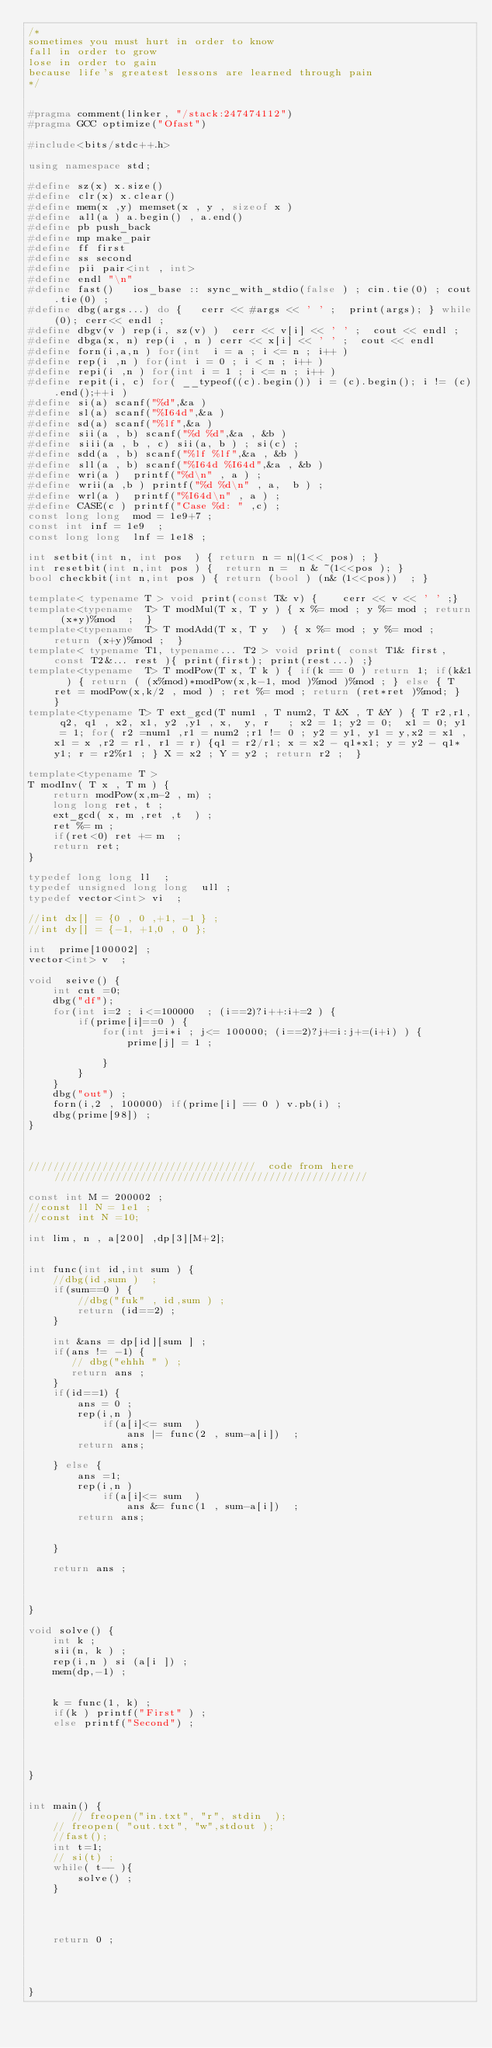<code> <loc_0><loc_0><loc_500><loc_500><_C++_>/*
sometimes you must hurt in order to know 
fall in order to grow
lose in order to gain  
because life's greatest lessons are learned through pain
*/


#pragma comment(linker, "/stack:247474112")
#pragma GCC optimize("Ofast")

#include<bits/stdc++.h>
 
using namespace std;
 
#define sz(x) x.size()
#define clr(x) x.clear()
#define mem(x ,y) memset(x , y , sizeof x )
#define all(a ) a.begin() , a.end()
#define pb push_back
#define mp make_pair
#define ff first
#define ss second
#define pii pair<int , int>
#define endl "\n"
#define fast()   ios_base :: sync_with_stdio(false ) ; cin.tie(0) ; cout.tie(0) ;
#define dbg(args...) do {   cerr << #args << ' ' ;  print(args); } while(0); cerr<< endl ;
#define dbgv(v ) rep(i, sz(v) )  cerr << v[i] << ' ' ;  cout << endl ;
#define dbga(x, n) rep(i , n ) cerr << x[i] << ' ' ;  cout << endl
#define forn(i,a,n ) for(int  i = a ; i <= n ; i++ )
#define rep(i ,n ) for(int i = 0 ; i < n ; i++ )
#define repi(i ,n ) for(int i = 1 ; i <= n ; i++ )
#define repit(i, c) for( __typeof((c).begin()) i = (c).begin(); i != (c).end();++i )
#define si(a) scanf("%d",&a )
#define sl(a) scanf("%I64d",&a )
#define sd(a) scanf("%lf",&a )
#define sii(a , b) scanf("%d %d",&a , &b )
#define siii(a , b , c) sii(a, b ) ; si(c) ;
#define sdd(a , b) scanf("%lf %lf",&a , &b )
#define sll(a , b) scanf("%I64d %I64d",&a , &b )
#define wri(a )  printf("%d\n" , a ) ;
#define wrii(a ,b ) printf("%d %d\n" , a,  b ) ;
#define wrl(a )  printf("%I64d\n" , a ) ;
#define CASE(c ) printf("Case %d: " ,c) ;
const long long  mod = 1e9+7 ;
const int inf = 1e9  ;
const long long  lnf = 1e18 ;
 
int setbit(int n, int pos  ) { return n = n|(1<< pos) ; }
int resetbit(int n,int pos ) {  return n =  n & ~(1<<pos ); }
bool checkbit(int n,int pos ) { return (bool ) (n& (1<<pos))  ; }

template< typename T > void print(const T& v) {    cerr << v << ' ' ;}
template<typename  T> T modMul(T x, T y ) { x %= mod ; y %= mod ; return (x*y)%mod  ;  }
template<typename  T> T modAdd(T x, T y  ) { x %= mod ; y %= mod ; return (x+y)%mod ;  }
template< typename T1, typename... T2 > void print( const T1& first, const T2&... rest ){ print(first); print(rest...) ;}
template<typename  T> T modPow(T x, T k ) { if(k == 0 ) return 1; if(k&1  ) { return ( (x%mod)*modPow(x,k-1, mod )%mod )%mod ; } else { T ret = modPow(x,k/2 , mod ) ; ret %= mod ; return (ret*ret )%mod; } }
template<typename T> T ext_gcd(T num1 , T num2, T &X , T &Y ) { T r2,r1, q2, q1 , x2, x1, y2 ,y1 , x,  y, r   ; x2 = 1; y2 = 0;  x1 = 0; y1 = 1; for( r2 =num1 ,r1 = num2 ;r1 != 0 ; y2 = y1, y1 = y,x2 = x1 ,x1 = x ,r2 = r1, r1 = r) {q1 = r2/r1; x = x2 - q1*x1; y = y2 - q1*y1; r = r2%r1 ; } X = x2 ; Y = y2 ; return r2 ;  } 

template<typename T >
T modInv( T x , T m ) {  
    return modPow(x,m-2 , m) ; 
    long long ret, t ;
    ext_gcd( x, m ,ret ,t  ) ;
    ret %= m ;
    if(ret<0) ret += m  ;
    return ret;
}

typedef long long ll  ;
typedef unsigned long long  ull ;
typedef vector<int> vi  ;

//int dx[] = {0 , 0 ,+1, -1 } ;
//int dy[] = {-1, +1,0 , 0 };

int  prime[100002] ; 
vector<int> v  ;

void  seive() {
    int cnt =0; 
    dbg("df");
    for(int i=2 ; i<=100000  ; (i==2)?i++:i+=2 ) {
        if(prime[i]==0 ) {
            for(int j=i*i ; j<= 100000; (i==2)?j+=i:j+=(i+i) ) {
                prime[j] = 1 ; 
                
            }
        }
    }
    dbg("out") ;
    forn(i,2 , 100000) if(prime[i] == 0 ) v.pb(i) ; 
    dbg(prime[98]) ;
}


 
/////////////////////////////////////  code from here ///////////////////////////////////////////////////

const int M = 200002 ;  
//const ll N = 1e1 ;
//const int N =10;

int lim, n , a[200] ,dp[3][M+2];


int func(int id,int sum ) {
    //dbg(id,sum )  ;
    if(sum==0 ) {
        //dbg("fuk" , id,sum ) ;
        return (id==2) ;
    }

    int &ans = dp[id][sum ] ;
    if(ans != -1) {
       // dbg("ehhh " ) ;
       return ans ;
    }
    if(id==1) {
        ans = 0 ;
        rep(i,n ) 
            if(a[i]<= sum  )
                ans |= func(2 , sum-a[i])  ;
        return ans; 

    } else {
        ans =1;
        rep(i,n ) 
            if(a[i]<= sum  )
                ans &= func(1 , sum-a[i])  ;
        return ans; 
        

    }

    return ans ; 



}

void solve() {  
    int k ; 
    sii(n, k ) ;
    rep(i,n ) si (a[i ]) ;
    mem(dp,-1) ;
    

    k = func(1, k) ;
    if(k ) printf("First" ) ;
    else printf("Second") ;




}


int main() {
       // freopen("in.txt", "r", stdin  );
    // freopen( "out.txt", "w",stdout );     
    //fast(); 
    int t=1; 
    // si(t) ;
    while( t-- ){
        solve() ;
    }




    return 0 ;




}

 
 
    </code> 